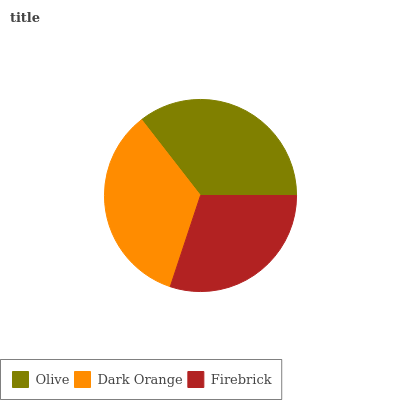Is Firebrick the minimum?
Answer yes or no. Yes. Is Olive the maximum?
Answer yes or no. Yes. Is Dark Orange the minimum?
Answer yes or no. No. Is Dark Orange the maximum?
Answer yes or no. No. Is Olive greater than Dark Orange?
Answer yes or no. Yes. Is Dark Orange less than Olive?
Answer yes or no. Yes. Is Dark Orange greater than Olive?
Answer yes or no. No. Is Olive less than Dark Orange?
Answer yes or no. No. Is Dark Orange the high median?
Answer yes or no. Yes. Is Dark Orange the low median?
Answer yes or no. Yes. Is Firebrick the high median?
Answer yes or no. No. Is Olive the low median?
Answer yes or no. No. 